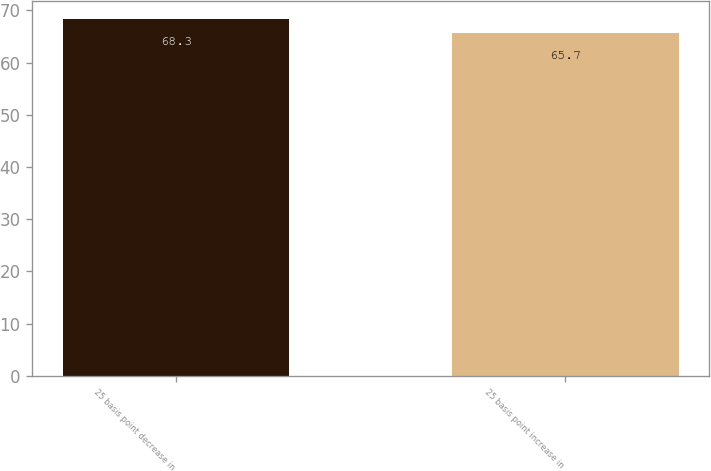Convert chart to OTSL. <chart><loc_0><loc_0><loc_500><loc_500><bar_chart><fcel>25 basis point decrease in<fcel>25 basis point increase in<nl><fcel>68.3<fcel>65.7<nl></chart> 